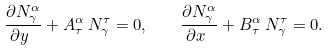Convert formula to latex. <formula><loc_0><loc_0><loc_500><loc_500>\frac { \partial N ^ { \alpha } _ { \gamma } } { \partial y \ } + A ^ { \alpha } _ { \tau } \, N ^ { \tau } _ { \gamma } = 0 , \quad \frac { \partial N ^ { \alpha } _ { \gamma } } { \partial x \ } + B ^ { \alpha } _ { \tau } \, N ^ { \tau } _ { \gamma } = 0 .</formula> 